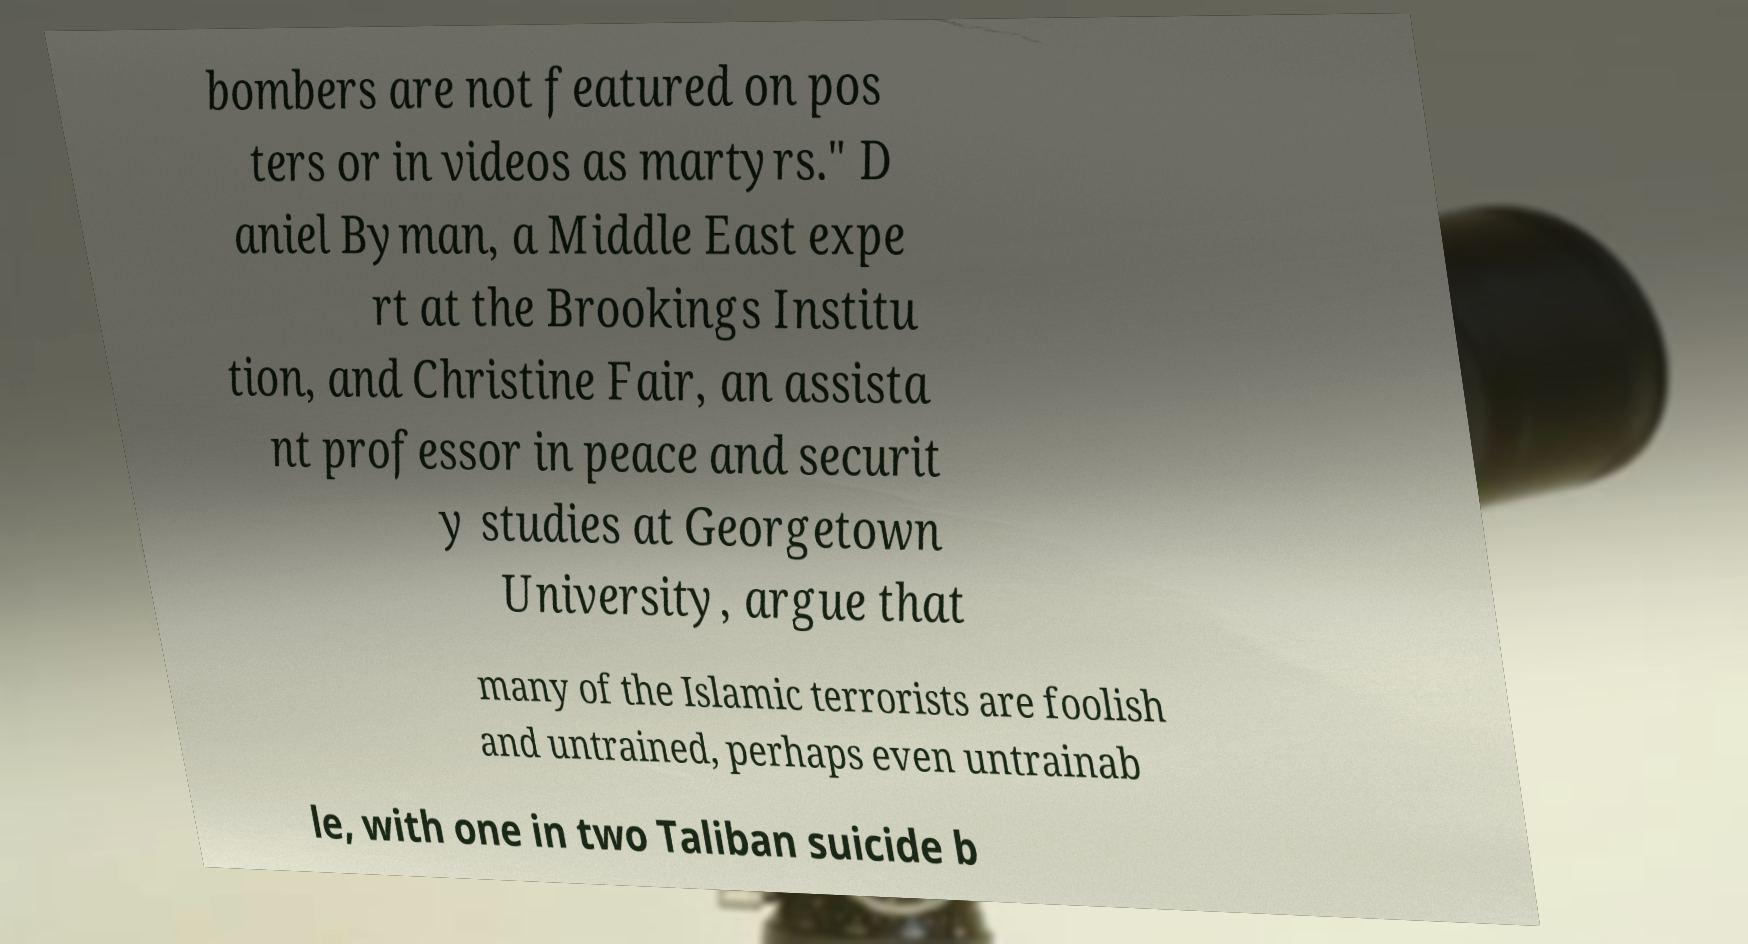Can you read and provide the text displayed in the image?This photo seems to have some interesting text. Can you extract and type it out for me? bombers are not featured on pos ters or in videos as martyrs." D aniel Byman, a Middle East expe rt at the Brookings Institu tion, and Christine Fair, an assista nt professor in peace and securit y studies at Georgetown University, argue that many of the Islamic terrorists are foolish and untrained, perhaps even untrainab le, with one in two Taliban suicide b 